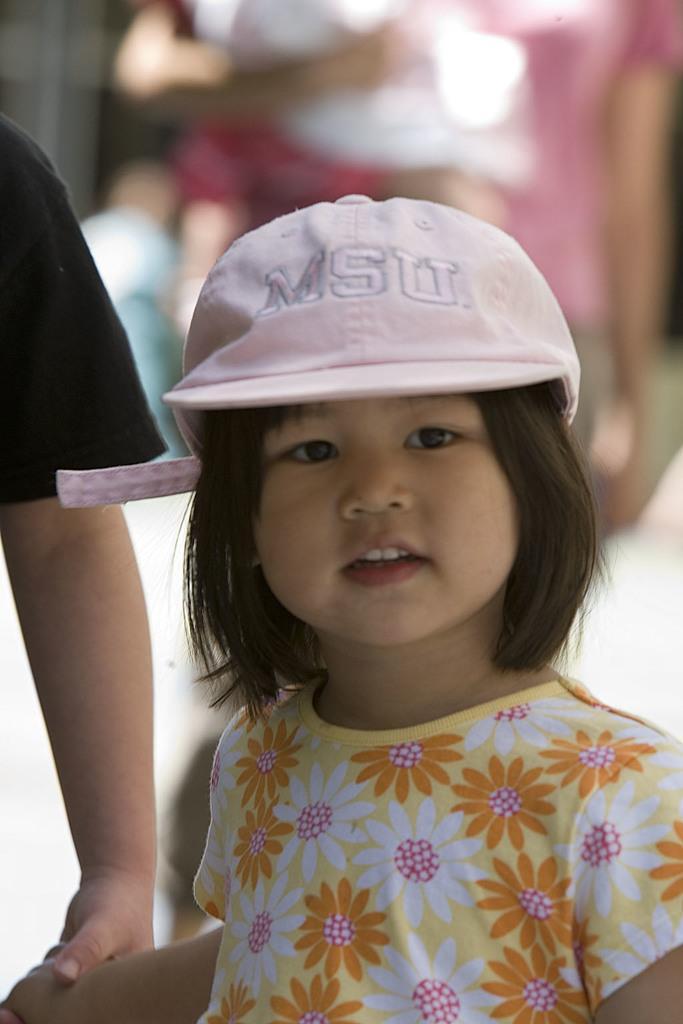In one or two sentences, can you explain what this image depicts? This image consists of a girl wearing a cap. Beside her, there is a person wearing black T-shirt is holding her hand. In the background, there are people walking. 